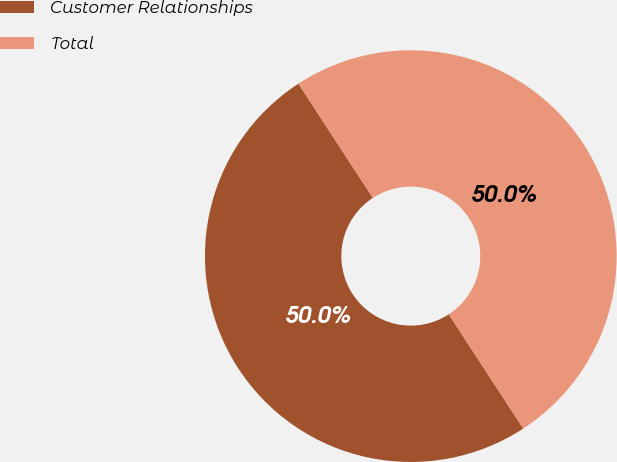Convert chart. <chart><loc_0><loc_0><loc_500><loc_500><pie_chart><fcel>Customer Relationships<fcel>Total<nl><fcel>50.0%<fcel>50.0%<nl></chart> 